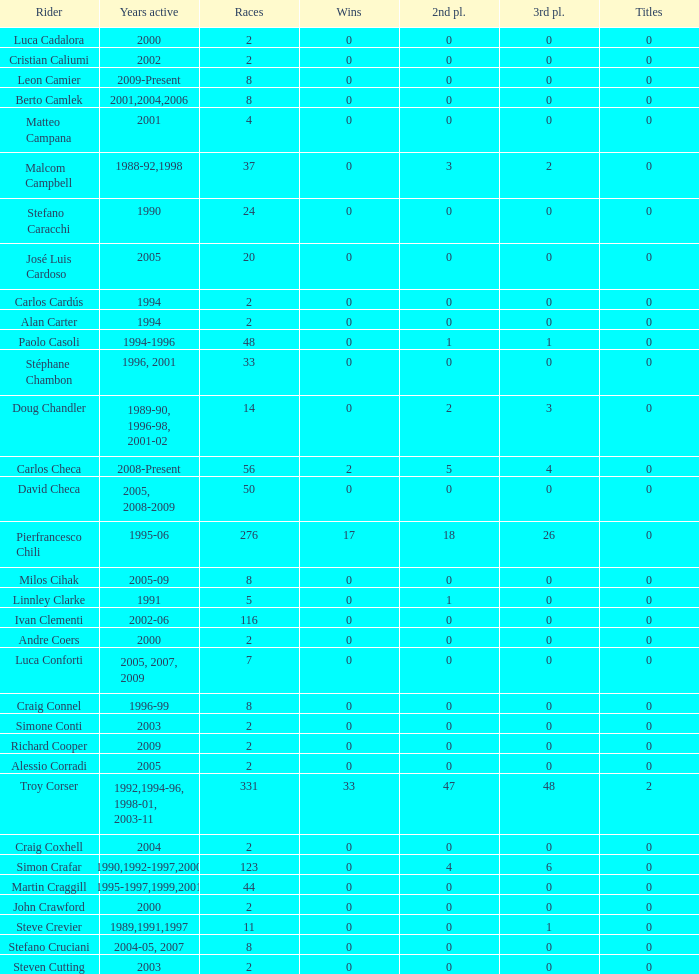What is the cumulative number of wins for racers with a race count below 56 and a title count greater than 0? 0.0. 